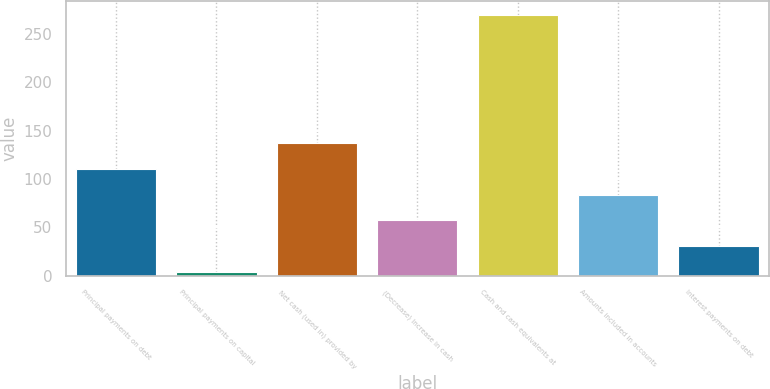Convert chart to OTSL. <chart><loc_0><loc_0><loc_500><loc_500><bar_chart><fcel>Principal payments on debt<fcel>Principal payments on capital<fcel>Net cash (used in) provided by<fcel>(Decrease) Increase in cash<fcel>Cash and cash equivalents at<fcel>Amounts included in accounts<fcel>Interest payments on debt<nl><fcel>110.4<fcel>4<fcel>137<fcel>57.2<fcel>270<fcel>83.8<fcel>30.6<nl></chart> 